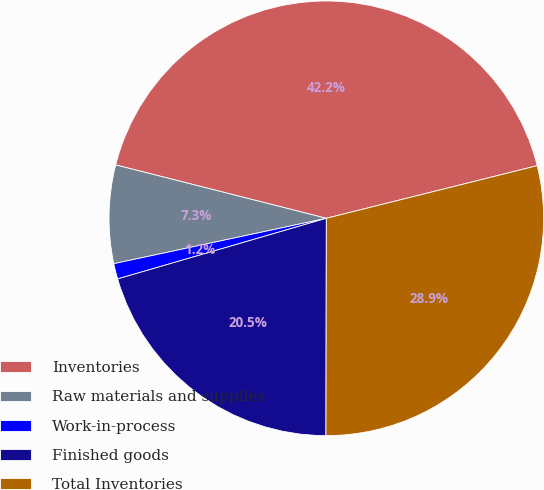<chart> <loc_0><loc_0><loc_500><loc_500><pie_chart><fcel>Inventories<fcel>Raw materials and supplies<fcel>Work-in-process<fcel>Finished goods<fcel>Total Inventories<nl><fcel>42.15%<fcel>7.3%<fcel>1.15%<fcel>20.47%<fcel>28.92%<nl></chart> 